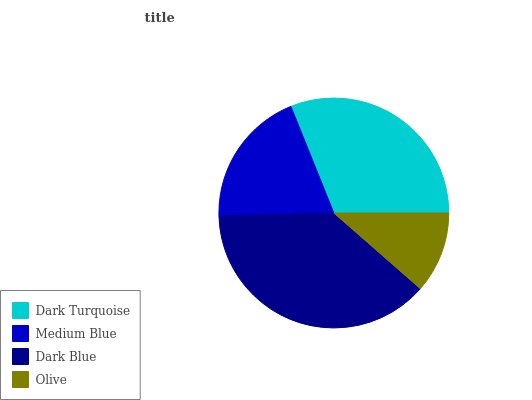Is Olive the minimum?
Answer yes or no. Yes. Is Dark Blue the maximum?
Answer yes or no. Yes. Is Medium Blue the minimum?
Answer yes or no. No. Is Medium Blue the maximum?
Answer yes or no. No. Is Dark Turquoise greater than Medium Blue?
Answer yes or no. Yes. Is Medium Blue less than Dark Turquoise?
Answer yes or no. Yes. Is Medium Blue greater than Dark Turquoise?
Answer yes or no. No. Is Dark Turquoise less than Medium Blue?
Answer yes or no. No. Is Dark Turquoise the high median?
Answer yes or no. Yes. Is Medium Blue the low median?
Answer yes or no. Yes. Is Olive the high median?
Answer yes or no. No. Is Olive the low median?
Answer yes or no. No. 